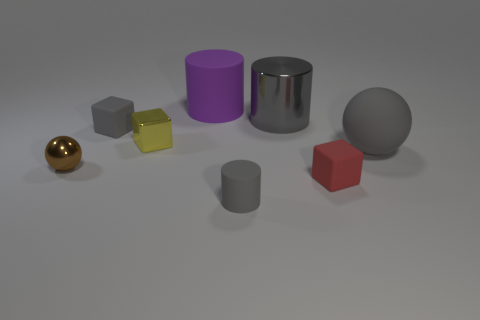Are there any other things that have the same shape as the purple matte thing?
Offer a terse response. Yes. Are any tiny purple blocks visible?
Make the answer very short. No. Do the red thing and the big gray object that is left of the gray rubber ball have the same shape?
Give a very brief answer. No. There is a sphere that is right of the cylinder that is right of the gray matte cylinder; what is its material?
Make the answer very short. Rubber. The small shiny block is what color?
Your answer should be very brief. Yellow. There is a tiny matte cube that is behind the yellow shiny object; is it the same color as the tiny shiny object that is in front of the large rubber sphere?
Keep it short and to the point. No. What size is the other matte object that is the same shape as the brown object?
Your answer should be very brief. Large. Is there another cylinder of the same color as the metal cylinder?
Your response must be concise. Yes. There is another cylinder that is the same color as the small matte cylinder; what is its material?
Offer a very short reply. Metal. What number of big balls have the same color as the small rubber cylinder?
Keep it short and to the point. 1. 